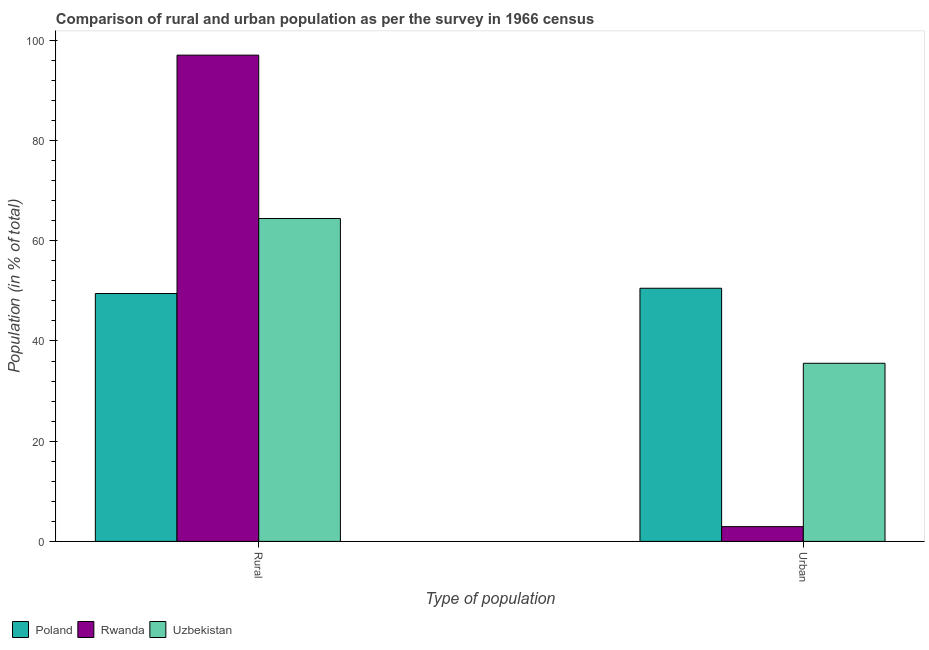How many different coloured bars are there?
Keep it short and to the point. 3. Are the number of bars per tick equal to the number of legend labels?
Give a very brief answer. Yes. How many bars are there on the 1st tick from the left?
Keep it short and to the point. 3. What is the label of the 1st group of bars from the left?
Give a very brief answer. Rural. What is the rural population in Uzbekistan?
Make the answer very short. 64.45. Across all countries, what is the maximum rural population?
Give a very brief answer. 97.06. Across all countries, what is the minimum rural population?
Provide a short and direct response. 49.47. In which country was the rural population minimum?
Ensure brevity in your answer.  Poland. What is the total urban population in the graph?
Your answer should be compact. 89.02. What is the difference between the rural population in Rwanda and that in Uzbekistan?
Your answer should be compact. 32.61. What is the difference between the urban population in Rwanda and the rural population in Uzbekistan?
Give a very brief answer. -61.5. What is the average urban population per country?
Offer a very short reply. 29.67. What is the difference between the urban population and rural population in Rwanda?
Make the answer very short. -94.12. What is the ratio of the rural population in Poland to that in Uzbekistan?
Keep it short and to the point. 0.77. In how many countries, is the urban population greater than the average urban population taken over all countries?
Offer a terse response. 2. What does the 2nd bar from the left in Urban represents?
Make the answer very short. Rwanda. What does the 2nd bar from the right in Rural represents?
Offer a very short reply. Rwanda. How many bars are there?
Your answer should be very brief. 6. Are all the bars in the graph horizontal?
Keep it short and to the point. No. How many countries are there in the graph?
Your answer should be very brief. 3. Does the graph contain any zero values?
Provide a succinct answer. No. Does the graph contain grids?
Make the answer very short. No. How many legend labels are there?
Offer a very short reply. 3. How are the legend labels stacked?
Give a very brief answer. Horizontal. What is the title of the graph?
Your answer should be compact. Comparison of rural and urban population as per the survey in 1966 census. Does "East Asia (all income levels)" appear as one of the legend labels in the graph?
Ensure brevity in your answer.  No. What is the label or title of the X-axis?
Offer a very short reply. Type of population. What is the label or title of the Y-axis?
Give a very brief answer. Population (in % of total). What is the Population (in % of total) in Poland in Rural?
Give a very brief answer. 49.47. What is the Population (in % of total) of Rwanda in Rural?
Ensure brevity in your answer.  97.06. What is the Population (in % of total) in Uzbekistan in Rural?
Your answer should be very brief. 64.45. What is the Population (in % of total) in Poland in Urban?
Offer a terse response. 50.53. What is the Population (in % of total) of Rwanda in Urban?
Keep it short and to the point. 2.94. What is the Population (in % of total) in Uzbekistan in Urban?
Provide a succinct answer. 35.55. Across all Type of population, what is the maximum Population (in % of total) in Poland?
Give a very brief answer. 50.53. Across all Type of population, what is the maximum Population (in % of total) of Rwanda?
Offer a very short reply. 97.06. Across all Type of population, what is the maximum Population (in % of total) in Uzbekistan?
Offer a terse response. 64.45. Across all Type of population, what is the minimum Population (in % of total) of Poland?
Your response must be concise. 49.47. Across all Type of population, what is the minimum Population (in % of total) in Rwanda?
Your answer should be compact. 2.94. Across all Type of population, what is the minimum Population (in % of total) in Uzbekistan?
Provide a succinct answer. 35.55. What is the difference between the Population (in % of total) in Poland in Rural and that in Urban?
Your response must be concise. -1.05. What is the difference between the Population (in % of total) in Rwanda in Rural and that in Urban?
Keep it short and to the point. 94.12. What is the difference between the Population (in % of total) of Uzbekistan in Rural and that in Urban?
Your answer should be very brief. 28.89. What is the difference between the Population (in % of total) in Poland in Rural and the Population (in % of total) in Rwanda in Urban?
Provide a succinct answer. 46.53. What is the difference between the Population (in % of total) of Poland in Rural and the Population (in % of total) of Uzbekistan in Urban?
Offer a terse response. 13.92. What is the difference between the Population (in % of total) in Rwanda in Rural and the Population (in % of total) in Uzbekistan in Urban?
Give a very brief answer. 61.5. What is the average Population (in % of total) in Poland per Type of population?
Ensure brevity in your answer.  50. What is the average Population (in % of total) in Rwanda per Type of population?
Your answer should be compact. 50. What is the average Population (in % of total) in Uzbekistan per Type of population?
Provide a short and direct response. 50. What is the difference between the Population (in % of total) in Poland and Population (in % of total) in Rwanda in Rural?
Your answer should be compact. -47.58. What is the difference between the Population (in % of total) in Poland and Population (in % of total) in Uzbekistan in Rural?
Your answer should be compact. -14.97. What is the difference between the Population (in % of total) in Rwanda and Population (in % of total) in Uzbekistan in Rural?
Keep it short and to the point. 32.61. What is the difference between the Population (in % of total) in Poland and Population (in % of total) in Rwanda in Urban?
Give a very brief answer. 47.58. What is the difference between the Population (in % of total) in Poland and Population (in % of total) in Uzbekistan in Urban?
Make the answer very short. 14.97. What is the difference between the Population (in % of total) of Rwanda and Population (in % of total) of Uzbekistan in Urban?
Your answer should be very brief. -32.61. What is the ratio of the Population (in % of total) of Poland in Rural to that in Urban?
Offer a terse response. 0.98. What is the ratio of the Population (in % of total) in Rwanda in Rural to that in Urban?
Offer a very short reply. 32.99. What is the ratio of the Population (in % of total) of Uzbekistan in Rural to that in Urban?
Provide a short and direct response. 1.81. What is the difference between the highest and the second highest Population (in % of total) of Poland?
Provide a short and direct response. 1.05. What is the difference between the highest and the second highest Population (in % of total) in Rwanda?
Ensure brevity in your answer.  94.12. What is the difference between the highest and the second highest Population (in % of total) in Uzbekistan?
Keep it short and to the point. 28.89. What is the difference between the highest and the lowest Population (in % of total) of Poland?
Offer a very short reply. 1.05. What is the difference between the highest and the lowest Population (in % of total) of Rwanda?
Offer a terse response. 94.12. What is the difference between the highest and the lowest Population (in % of total) of Uzbekistan?
Offer a very short reply. 28.89. 